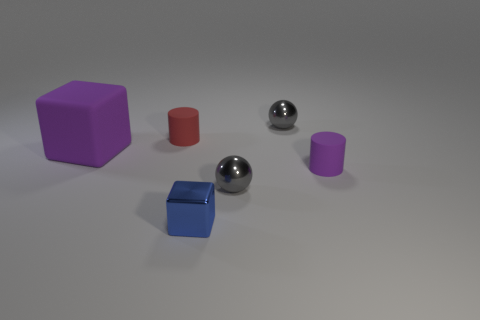Are there any other things that have the same size as the red matte thing? Yes, the purple matte cylinder appears to be roughly the same size in height as the red matte cylinder. Assessing size can be tricky without precise measurement tools, but visually comparing the objects suggest they are of comparable dimensions. 